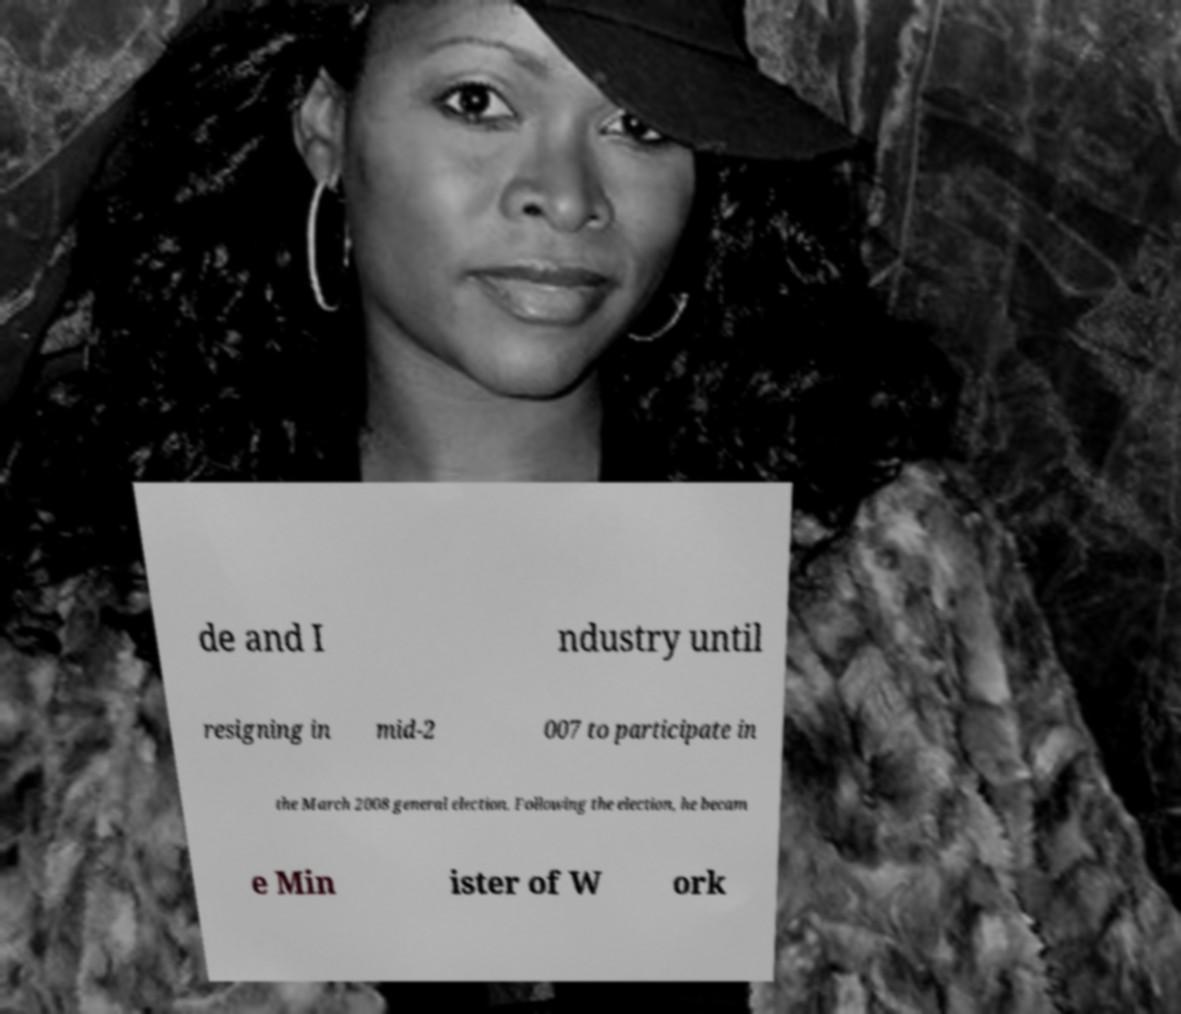For documentation purposes, I need the text within this image transcribed. Could you provide that? de and I ndustry until resigning in mid-2 007 to participate in the March 2008 general election. Following the election, he becam e Min ister of W ork 